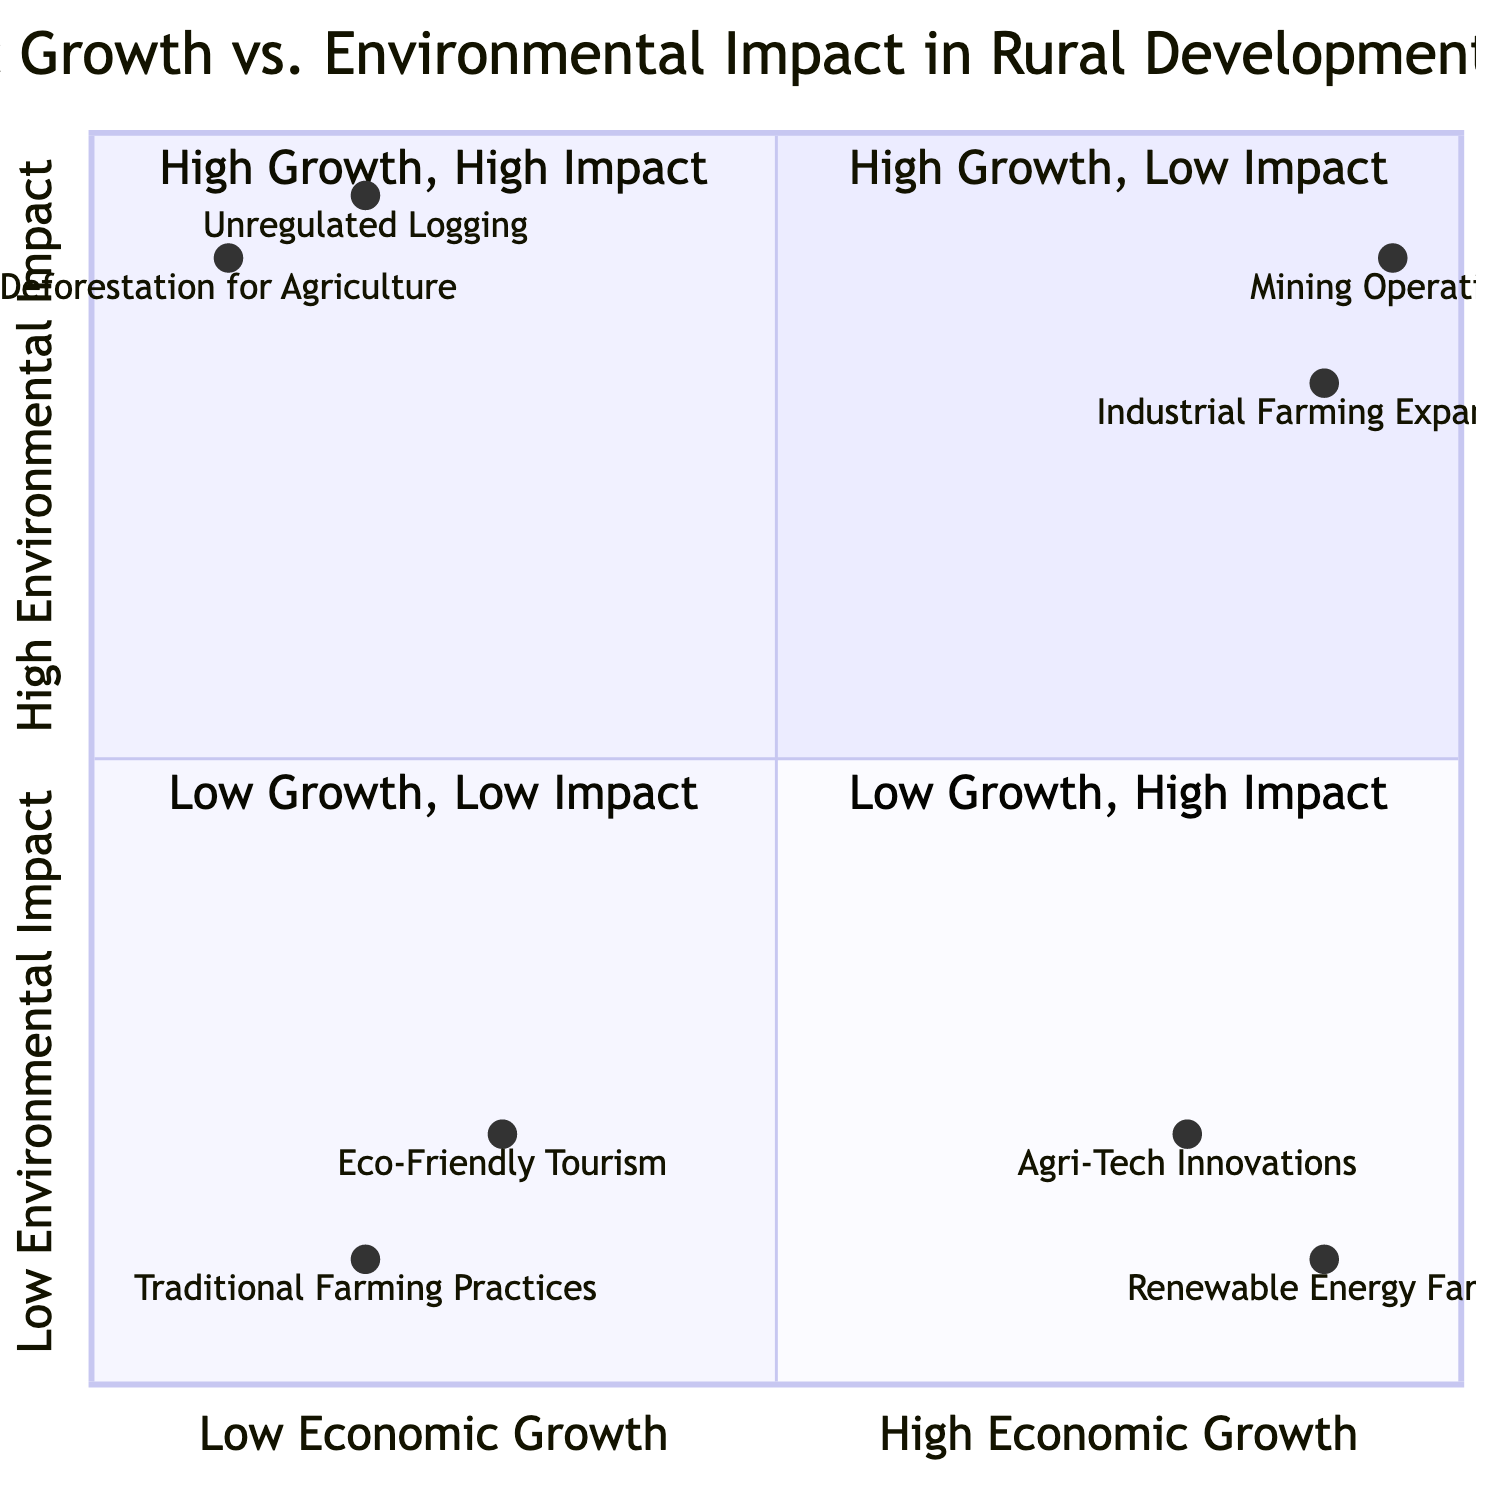What project is located in Lancaster, Pennsylvania? The project in Lancaster, Pennsylvania is "Agri-Tech Innovations." This information is directly available in the diagram under the quadrant for High Economic Growth, Low Environmental Impact.
Answer: Agri-Tech Innovations How many projects have high economic growth and high environmental impact? The diagram shows two projects in the quadrant for High Economic Growth, High Environmental Impact: "Industrial Farming Expansion" and "Mining Operations." Therefore, the total is two projects.
Answer: 2 Which project has the lowest economic growth? The project with the lowest economic growth is "Deforestation for Agriculture," positioned in the Low Economic Growth, High Environmental Impact quadrant. This is determined by reviewing the project locations in that specific quadrant.
Answer: Deforestation for Agriculture What is the environmental impact range of eco-friendly tourism? "Eco-Friendly Tourism" has a low environmental impact, specifically 0.2 on the chart. To find this, one can observe its position on the y-axis representing Environmental Impact.
Answer: 0.2 What do the projects in the Low Economic Growth, Low Environmental Impact quadrant generally represent? The projects in this quadrant, such as "Traditional Farming Practices" and "Eco-Friendly Tourism," typically indicate sustainable practices that focus on minimal environmental impacts while having limited economic growth potential. This interpretation comes from analyzing the characteristics of the quadrant.
Answer: Sustainable practices What patterns can be observed for projects in the High Economic Growth quadrant? In the High Economic Growth quadrants, there’s a discernible pattern where projects like "Agri-Tech Innovations" and "Renewable Energy Farms" demonstrate low environmental impacts, while "Industrial Farming Expansion" and "Mining Operations" showcase high environmental impacts. This evaluation is based on their respective placements in the chart and their defined impacts.
Answer: Varying environmental impacts Which quadrant has the most environmental concerns? The quadrant with the most environmental concerns is "High Economic Growth, High Environmental Impact," as evidenced by the high pollution and degradation effects associated with the projects listed there, such as "Mining Operations." This conclusion is drawn from examining both the quadrant's title and the provided project descriptions.
Answer: High Economic Growth, High Environmental Impact 